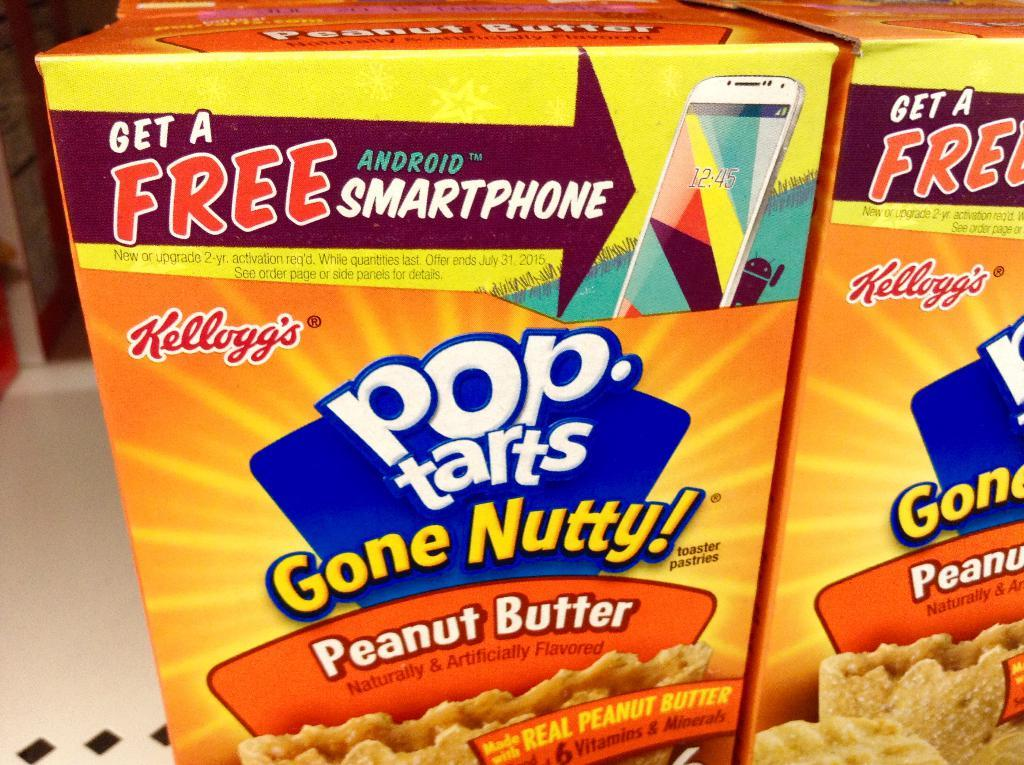<image>
Create a compact narrative representing the image presented. Pop Tarts is offering for customers to 'Get a free Android Smartphone' on it's Peanut Butter flavored Pop Tart boxes.. 